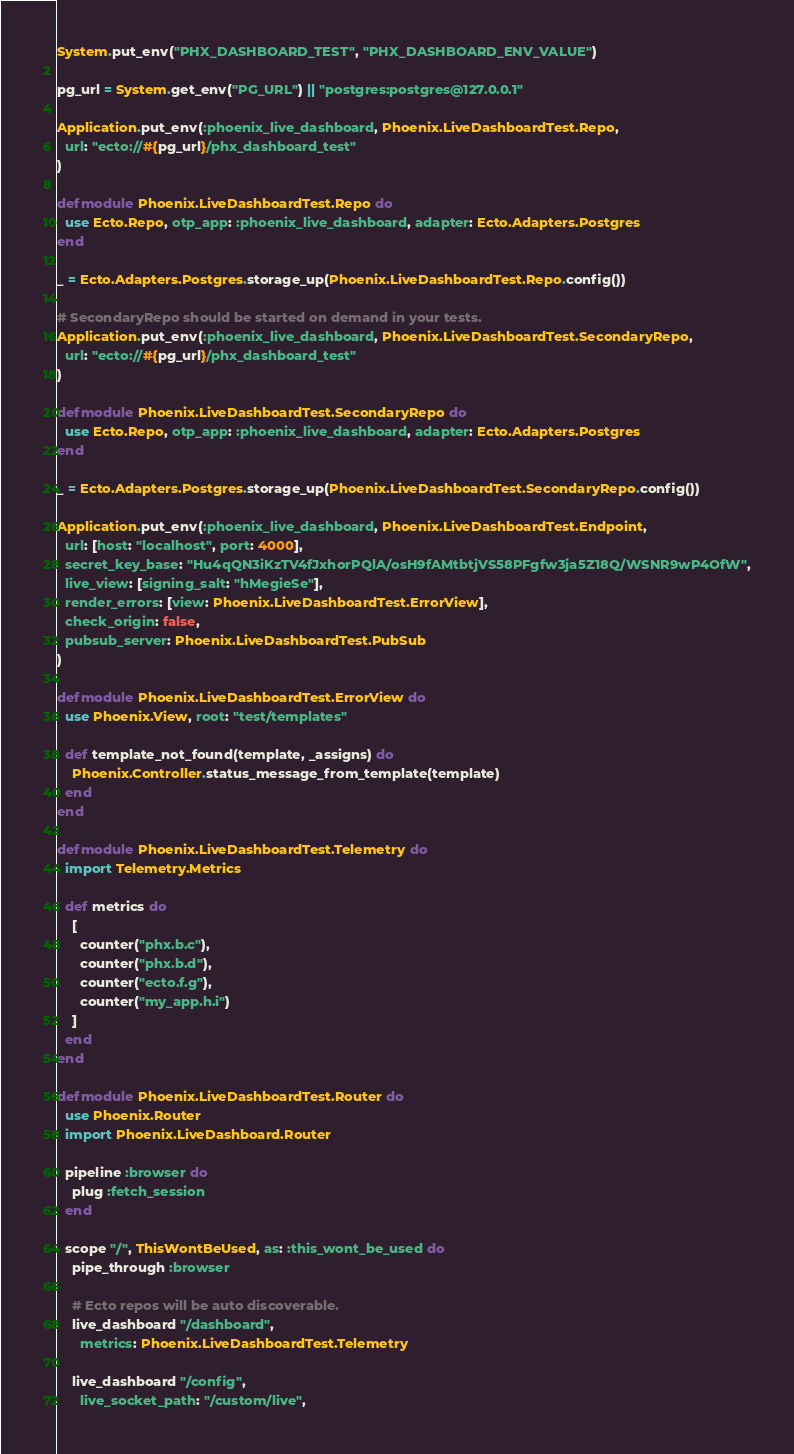<code> <loc_0><loc_0><loc_500><loc_500><_Elixir_>System.put_env("PHX_DASHBOARD_TEST", "PHX_DASHBOARD_ENV_VALUE")

pg_url = System.get_env("PG_URL") || "postgres:postgres@127.0.0.1"

Application.put_env(:phoenix_live_dashboard, Phoenix.LiveDashboardTest.Repo,
  url: "ecto://#{pg_url}/phx_dashboard_test"
)

defmodule Phoenix.LiveDashboardTest.Repo do
  use Ecto.Repo, otp_app: :phoenix_live_dashboard, adapter: Ecto.Adapters.Postgres
end

_ = Ecto.Adapters.Postgres.storage_up(Phoenix.LiveDashboardTest.Repo.config())

# SecondaryRepo should be started on demand in your tests.
Application.put_env(:phoenix_live_dashboard, Phoenix.LiveDashboardTest.SecondaryRepo,
  url: "ecto://#{pg_url}/phx_dashboard_test"
)

defmodule Phoenix.LiveDashboardTest.SecondaryRepo do
  use Ecto.Repo, otp_app: :phoenix_live_dashboard, adapter: Ecto.Adapters.Postgres
end

_ = Ecto.Adapters.Postgres.storage_up(Phoenix.LiveDashboardTest.SecondaryRepo.config())

Application.put_env(:phoenix_live_dashboard, Phoenix.LiveDashboardTest.Endpoint,
  url: [host: "localhost", port: 4000],
  secret_key_base: "Hu4qQN3iKzTV4fJxhorPQlA/osH9fAMtbtjVS58PFgfw3ja5Z18Q/WSNR9wP4OfW",
  live_view: [signing_salt: "hMegieSe"],
  render_errors: [view: Phoenix.LiveDashboardTest.ErrorView],
  check_origin: false,
  pubsub_server: Phoenix.LiveDashboardTest.PubSub
)

defmodule Phoenix.LiveDashboardTest.ErrorView do
  use Phoenix.View, root: "test/templates"

  def template_not_found(template, _assigns) do
    Phoenix.Controller.status_message_from_template(template)
  end
end

defmodule Phoenix.LiveDashboardTest.Telemetry do
  import Telemetry.Metrics

  def metrics do
    [
      counter("phx.b.c"),
      counter("phx.b.d"),
      counter("ecto.f.g"),
      counter("my_app.h.i")
    ]
  end
end

defmodule Phoenix.LiveDashboardTest.Router do
  use Phoenix.Router
  import Phoenix.LiveDashboard.Router

  pipeline :browser do
    plug :fetch_session
  end

  scope "/", ThisWontBeUsed, as: :this_wont_be_used do
    pipe_through :browser

    # Ecto repos will be auto discoverable.
    live_dashboard "/dashboard",
      metrics: Phoenix.LiveDashboardTest.Telemetry

    live_dashboard "/config",
      live_socket_path: "/custom/live",</code> 